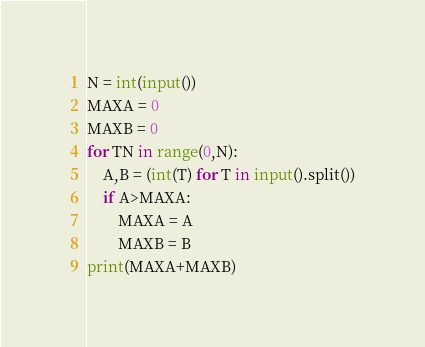<code> <loc_0><loc_0><loc_500><loc_500><_Python_>N = int(input())
MAXA = 0
MAXB = 0
for TN in range(0,N):
    A,B = (int(T) for T in input().split())
    if A>MAXA:
        MAXA = A
        MAXB = B
print(MAXA+MAXB)</code> 